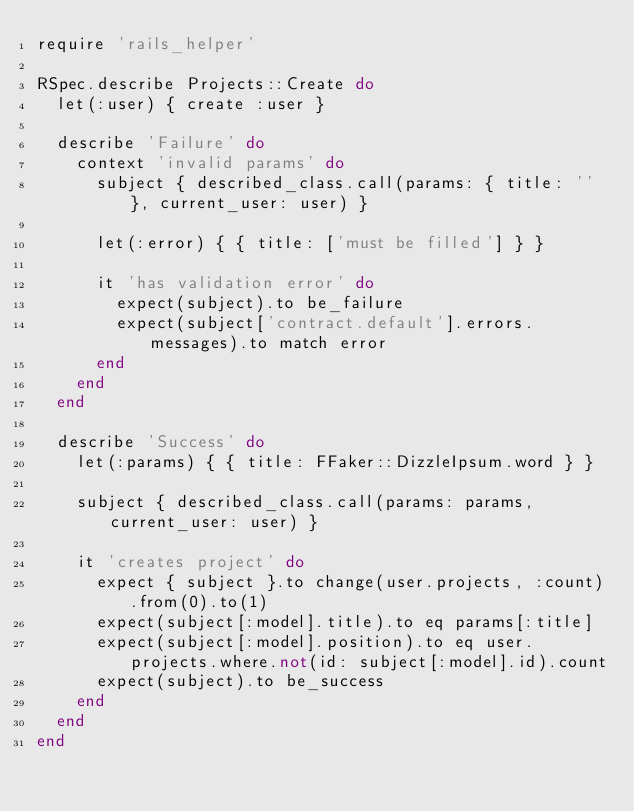<code> <loc_0><loc_0><loc_500><loc_500><_Ruby_>require 'rails_helper'

RSpec.describe Projects::Create do
  let(:user) { create :user }

  describe 'Failure' do
    context 'invalid params' do
      subject { described_class.call(params: { title: '' }, current_user: user) }

      let(:error) { { title: ['must be filled'] } }

      it 'has validation error' do
        expect(subject).to be_failure
        expect(subject['contract.default'].errors.messages).to match error
      end
    end
  end

  describe 'Success' do
    let(:params) { { title: FFaker::DizzleIpsum.word } }

    subject { described_class.call(params: params, current_user: user) }

    it 'creates project' do
      expect { subject }.to change(user.projects, :count).from(0).to(1)
      expect(subject[:model].title).to eq params[:title]
      expect(subject[:model].position).to eq user.projects.where.not(id: subject[:model].id).count
      expect(subject).to be_success
    end
  end
end
</code> 